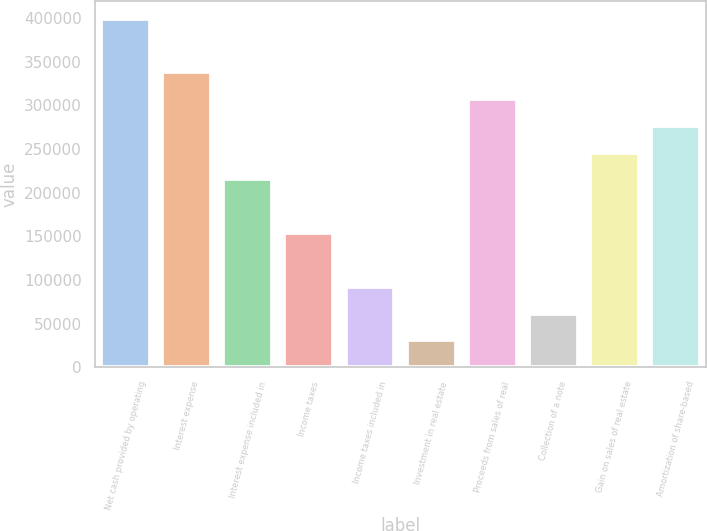Convert chart. <chart><loc_0><loc_0><loc_500><loc_500><bar_chart><fcel>Net cash provided by operating<fcel>Interest expense<fcel>Interest expense included in<fcel>Income taxes<fcel>Income taxes included in<fcel>Investment in real estate<fcel>Proceeds from sales of real<fcel>Collection of a note<fcel>Gain on sales of real estate<fcel>Amortization of share-based<nl><fcel>399494<fcel>338034<fcel>215114<fcel>153654<fcel>92193.4<fcel>30733.3<fcel>307304<fcel>61463.4<fcel>245844<fcel>276574<nl></chart> 